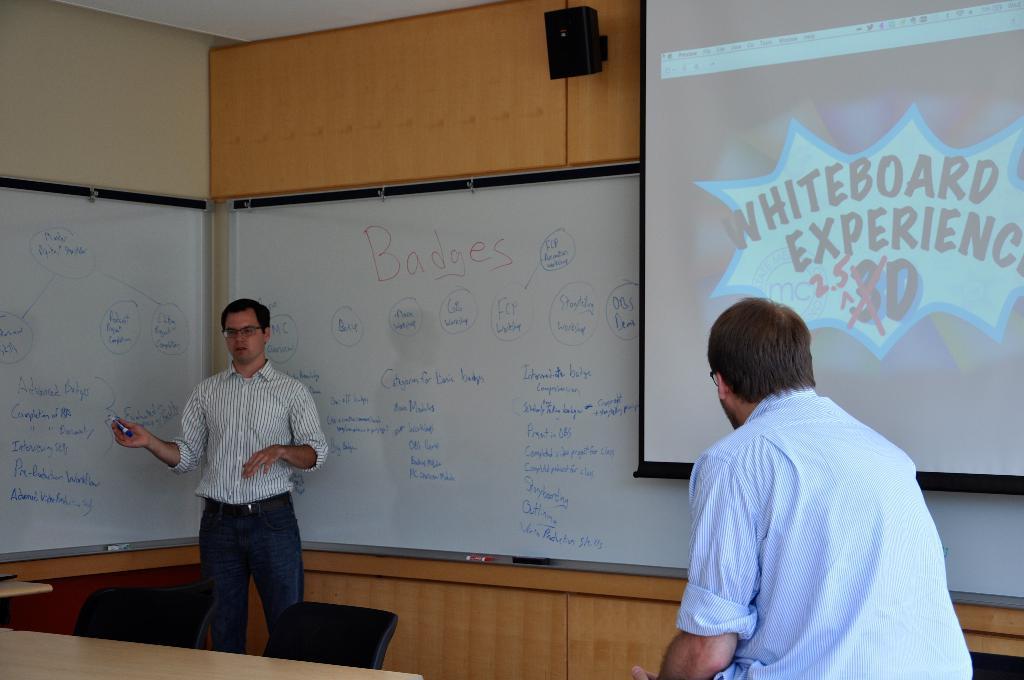Can you describe this image briefly? In this image, there is a person wearing clothes and standing in front of the board. There is a table and chairs in the bottom left of the image. There is an another person wearing clothes and sitting in front of the screen. There is a speaker at the top of the image. 